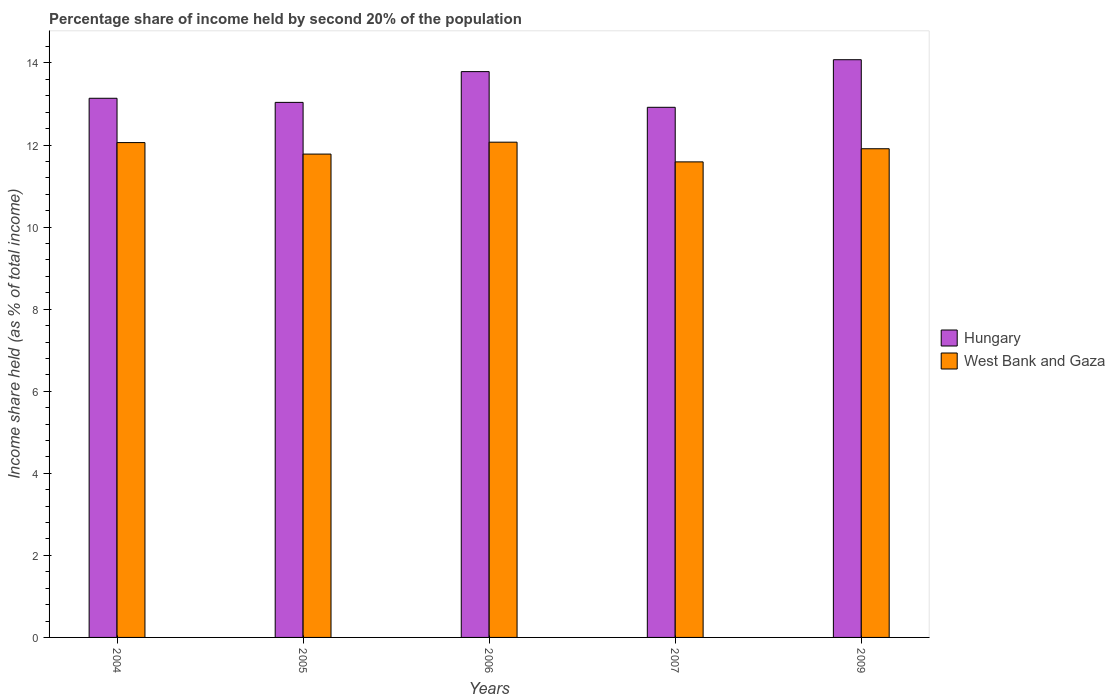How many different coloured bars are there?
Offer a terse response. 2. How many groups of bars are there?
Provide a short and direct response. 5. Are the number of bars on each tick of the X-axis equal?
Provide a short and direct response. Yes. What is the label of the 3rd group of bars from the left?
Offer a very short reply. 2006. What is the share of income held by second 20% of the population in Hungary in 2005?
Make the answer very short. 13.04. Across all years, what is the maximum share of income held by second 20% of the population in West Bank and Gaza?
Keep it short and to the point. 12.07. Across all years, what is the minimum share of income held by second 20% of the population in West Bank and Gaza?
Give a very brief answer. 11.59. What is the total share of income held by second 20% of the population in Hungary in the graph?
Give a very brief answer. 66.97. What is the difference between the share of income held by second 20% of the population in West Bank and Gaza in 2004 and that in 2006?
Your answer should be very brief. -0.01. What is the difference between the share of income held by second 20% of the population in Hungary in 2005 and the share of income held by second 20% of the population in West Bank and Gaza in 2004?
Your answer should be very brief. 0.98. What is the average share of income held by second 20% of the population in West Bank and Gaza per year?
Provide a short and direct response. 11.88. In the year 2006, what is the difference between the share of income held by second 20% of the population in Hungary and share of income held by second 20% of the population in West Bank and Gaza?
Your response must be concise. 1.72. What is the ratio of the share of income held by second 20% of the population in Hungary in 2004 to that in 2006?
Make the answer very short. 0.95. Is the share of income held by second 20% of the population in Hungary in 2007 less than that in 2009?
Provide a succinct answer. Yes. Is the difference between the share of income held by second 20% of the population in Hungary in 2004 and 2006 greater than the difference between the share of income held by second 20% of the population in West Bank and Gaza in 2004 and 2006?
Make the answer very short. No. What is the difference between the highest and the second highest share of income held by second 20% of the population in Hungary?
Offer a very short reply. 0.29. What is the difference between the highest and the lowest share of income held by second 20% of the population in West Bank and Gaza?
Provide a short and direct response. 0.48. Is the sum of the share of income held by second 20% of the population in Hungary in 2005 and 2007 greater than the maximum share of income held by second 20% of the population in West Bank and Gaza across all years?
Keep it short and to the point. Yes. What does the 2nd bar from the left in 2004 represents?
Provide a succinct answer. West Bank and Gaza. What does the 1st bar from the right in 2007 represents?
Keep it short and to the point. West Bank and Gaza. How many years are there in the graph?
Your answer should be compact. 5. What is the difference between two consecutive major ticks on the Y-axis?
Give a very brief answer. 2. Are the values on the major ticks of Y-axis written in scientific E-notation?
Offer a terse response. No. Does the graph contain any zero values?
Provide a short and direct response. No. How many legend labels are there?
Provide a short and direct response. 2. How are the legend labels stacked?
Provide a short and direct response. Vertical. What is the title of the graph?
Make the answer very short. Percentage share of income held by second 20% of the population. Does "Curacao" appear as one of the legend labels in the graph?
Your answer should be very brief. No. What is the label or title of the Y-axis?
Your answer should be compact. Income share held (as % of total income). What is the Income share held (as % of total income) of Hungary in 2004?
Give a very brief answer. 13.14. What is the Income share held (as % of total income) in West Bank and Gaza in 2004?
Provide a succinct answer. 12.06. What is the Income share held (as % of total income) in Hungary in 2005?
Ensure brevity in your answer.  13.04. What is the Income share held (as % of total income) of West Bank and Gaza in 2005?
Offer a very short reply. 11.78. What is the Income share held (as % of total income) in Hungary in 2006?
Give a very brief answer. 13.79. What is the Income share held (as % of total income) in West Bank and Gaza in 2006?
Make the answer very short. 12.07. What is the Income share held (as % of total income) of Hungary in 2007?
Ensure brevity in your answer.  12.92. What is the Income share held (as % of total income) in West Bank and Gaza in 2007?
Provide a succinct answer. 11.59. What is the Income share held (as % of total income) in Hungary in 2009?
Provide a short and direct response. 14.08. What is the Income share held (as % of total income) of West Bank and Gaza in 2009?
Provide a short and direct response. 11.91. Across all years, what is the maximum Income share held (as % of total income) of Hungary?
Offer a terse response. 14.08. Across all years, what is the maximum Income share held (as % of total income) in West Bank and Gaza?
Provide a succinct answer. 12.07. Across all years, what is the minimum Income share held (as % of total income) of Hungary?
Offer a very short reply. 12.92. Across all years, what is the minimum Income share held (as % of total income) in West Bank and Gaza?
Your response must be concise. 11.59. What is the total Income share held (as % of total income) in Hungary in the graph?
Ensure brevity in your answer.  66.97. What is the total Income share held (as % of total income) of West Bank and Gaza in the graph?
Make the answer very short. 59.41. What is the difference between the Income share held (as % of total income) of Hungary in 2004 and that in 2005?
Offer a terse response. 0.1. What is the difference between the Income share held (as % of total income) in West Bank and Gaza in 2004 and that in 2005?
Provide a short and direct response. 0.28. What is the difference between the Income share held (as % of total income) of Hungary in 2004 and that in 2006?
Offer a terse response. -0.65. What is the difference between the Income share held (as % of total income) in West Bank and Gaza in 2004 and that in 2006?
Ensure brevity in your answer.  -0.01. What is the difference between the Income share held (as % of total income) of Hungary in 2004 and that in 2007?
Your answer should be very brief. 0.22. What is the difference between the Income share held (as % of total income) of West Bank and Gaza in 2004 and that in 2007?
Ensure brevity in your answer.  0.47. What is the difference between the Income share held (as % of total income) in Hungary in 2004 and that in 2009?
Provide a succinct answer. -0.94. What is the difference between the Income share held (as % of total income) in West Bank and Gaza in 2004 and that in 2009?
Provide a short and direct response. 0.15. What is the difference between the Income share held (as % of total income) of Hungary in 2005 and that in 2006?
Provide a succinct answer. -0.75. What is the difference between the Income share held (as % of total income) of West Bank and Gaza in 2005 and that in 2006?
Offer a very short reply. -0.29. What is the difference between the Income share held (as % of total income) in Hungary in 2005 and that in 2007?
Your answer should be compact. 0.12. What is the difference between the Income share held (as % of total income) in West Bank and Gaza in 2005 and that in 2007?
Give a very brief answer. 0.19. What is the difference between the Income share held (as % of total income) in Hungary in 2005 and that in 2009?
Make the answer very short. -1.04. What is the difference between the Income share held (as % of total income) of West Bank and Gaza in 2005 and that in 2009?
Provide a short and direct response. -0.13. What is the difference between the Income share held (as % of total income) of Hungary in 2006 and that in 2007?
Offer a terse response. 0.87. What is the difference between the Income share held (as % of total income) of West Bank and Gaza in 2006 and that in 2007?
Offer a very short reply. 0.48. What is the difference between the Income share held (as % of total income) in Hungary in 2006 and that in 2009?
Your response must be concise. -0.29. What is the difference between the Income share held (as % of total income) of West Bank and Gaza in 2006 and that in 2009?
Ensure brevity in your answer.  0.16. What is the difference between the Income share held (as % of total income) of Hungary in 2007 and that in 2009?
Offer a very short reply. -1.16. What is the difference between the Income share held (as % of total income) of West Bank and Gaza in 2007 and that in 2009?
Ensure brevity in your answer.  -0.32. What is the difference between the Income share held (as % of total income) in Hungary in 2004 and the Income share held (as % of total income) in West Bank and Gaza in 2005?
Give a very brief answer. 1.36. What is the difference between the Income share held (as % of total income) of Hungary in 2004 and the Income share held (as % of total income) of West Bank and Gaza in 2006?
Your answer should be compact. 1.07. What is the difference between the Income share held (as % of total income) of Hungary in 2004 and the Income share held (as % of total income) of West Bank and Gaza in 2007?
Give a very brief answer. 1.55. What is the difference between the Income share held (as % of total income) of Hungary in 2004 and the Income share held (as % of total income) of West Bank and Gaza in 2009?
Ensure brevity in your answer.  1.23. What is the difference between the Income share held (as % of total income) in Hungary in 2005 and the Income share held (as % of total income) in West Bank and Gaza in 2006?
Provide a succinct answer. 0.97. What is the difference between the Income share held (as % of total income) of Hungary in 2005 and the Income share held (as % of total income) of West Bank and Gaza in 2007?
Ensure brevity in your answer.  1.45. What is the difference between the Income share held (as % of total income) of Hungary in 2005 and the Income share held (as % of total income) of West Bank and Gaza in 2009?
Your response must be concise. 1.13. What is the difference between the Income share held (as % of total income) in Hungary in 2006 and the Income share held (as % of total income) in West Bank and Gaza in 2009?
Provide a succinct answer. 1.88. What is the average Income share held (as % of total income) of Hungary per year?
Ensure brevity in your answer.  13.39. What is the average Income share held (as % of total income) in West Bank and Gaza per year?
Give a very brief answer. 11.88. In the year 2004, what is the difference between the Income share held (as % of total income) of Hungary and Income share held (as % of total income) of West Bank and Gaza?
Your answer should be compact. 1.08. In the year 2005, what is the difference between the Income share held (as % of total income) of Hungary and Income share held (as % of total income) of West Bank and Gaza?
Give a very brief answer. 1.26. In the year 2006, what is the difference between the Income share held (as % of total income) of Hungary and Income share held (as % of total income) of West Bank and Gaza?
Your answer should be compact. 1.72. In the year 2007, what is the difference between the Income share held (as % of total income) of Hungary and Income share held (as % of total income) of West Bank and Gaza?
Make the answer very short. 1.33. In the year 2009, what is the difference between the Income share held (as % of total income) in Hungary and Income share held (as % of total income) in West Bank and Gaza?
Offer a terse response. 2.17. What is the ratio of the Income share held (as % of total income) in Hungary in 2004 to that in 2005?
Your answer should be compact. 1.01. What is the ratio of the Income share held (as % of total income) of West Bank and Gaza in 2004 to that in 2005?
Ensure brevity in your answer.  1.02. What is the ratio of the Income share held (as % of total income) in Hungary in 2004 to that in 2006?
Keep it short and to the point. 0.95. What is the ratio of the Income share held (as % of total income) of West Bank and Gaza in 2004 to that in 2006?
Keep it short and to the point. 1. What is the ratio of the Income share held (as % of total income) of West Bank and Gaza in 2004 to that in 2007?
Give a very brief answer. 1.04. What is the ratio of the Income share held (as % of total income) of Hungary in 2004 to that in 2009?
Make the answer very short. 0.93. What is the ratio of the Income share held (as % of total income) in West Bank and Gaza in 2004 to that in 2009?
Your answer should be very brief. 1.01. What is the ratio of the Income share held (as % of total income) of Hungary in 2005 to that in 2006?
Provide a short and direct response. 0.95. What is the ratio of the Income share held (as % of total income) in Hungary in 2005 to that in 2007?
Your answer should be compact. 1.01. What is the ratio of the Income share held (as % of total income) of West Bank and Gaza in 2005 to that in 2007?
Your response must be concise. 1.02. What is the ratio of the Income share held (as % of total income) of Hungary in 2005 to that in 2009?
Give a very brief answer. 0.93. What is the ratio of the Income share held (as % of total income) in Hungary in 2006 to that in 2007?
Offer a terse response. 1.07. What is the ratio of the Income share held (as % of total income) in West Bank and Gaza in 2006 to that in 2007?
Your answer should be very brief. 1.04. What is the ratio of the Income share held (as % of total income) of Hungary in 2006 to that in 2009?
Provide a short and direct response. 0.98. What is the ratio of the Income share held (as % of total income) of West Bank and Gaza in 2006 to that in 2009?
Provide a succinct answer. 1.01. What is the ratio of the Income share held (as % of total income) of Hungary in 2007 to that in 2009?
Provide a short and direct response. 0.92. What is the ratio of the Income share held (as % of total income) of West Bank and Gaza in 2007 to that in 2009?
Keep it short and to the point. 0.97. What is the difference between the highest and the second highest Income share held (as % of total income) of Hungary?
Keep it short and to the point. 0.29. What is the difference between the highest and the lowest Income share held (as % of total income) of Hungary?
Provide a short and direct response. 1.16. What is the difference between the highest and the lowest Income share held (as % of total income) of West Bank and Gaza?
Your response must be concise. 0.48. 